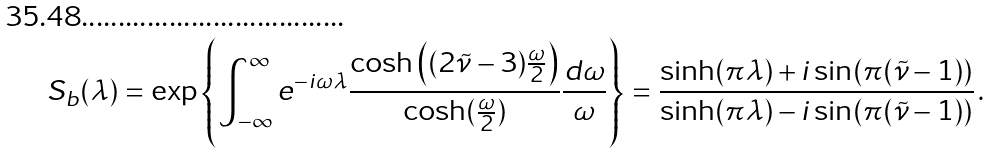<formula> <loc_0><loc_0><loc_500><loc_500>S _ { b } ( \lambda ) = \exp \left \{ \int _ { - \infty } ^ { \infty } e ^ { - i \omega \lambda } { \frac { \cosh \left ( ( 2 \tilde { \nu } - 3 ) { \frac { \omega } { 2 } } \right ) } { \cosh ( { \frac { \omega } { 2 } } ) } } { \frac { d \omega } { \omega } } \right \} = { \frac { \sinh ( \pi \lambda ) + i \sin ( \pi ( \tilde { \nu } - 1 ) ) } { \sinh ( \pi \lambda ) - i \sin ( \pi ( \tilde { \nu } - 1 ) ) } } \, .</formula> 